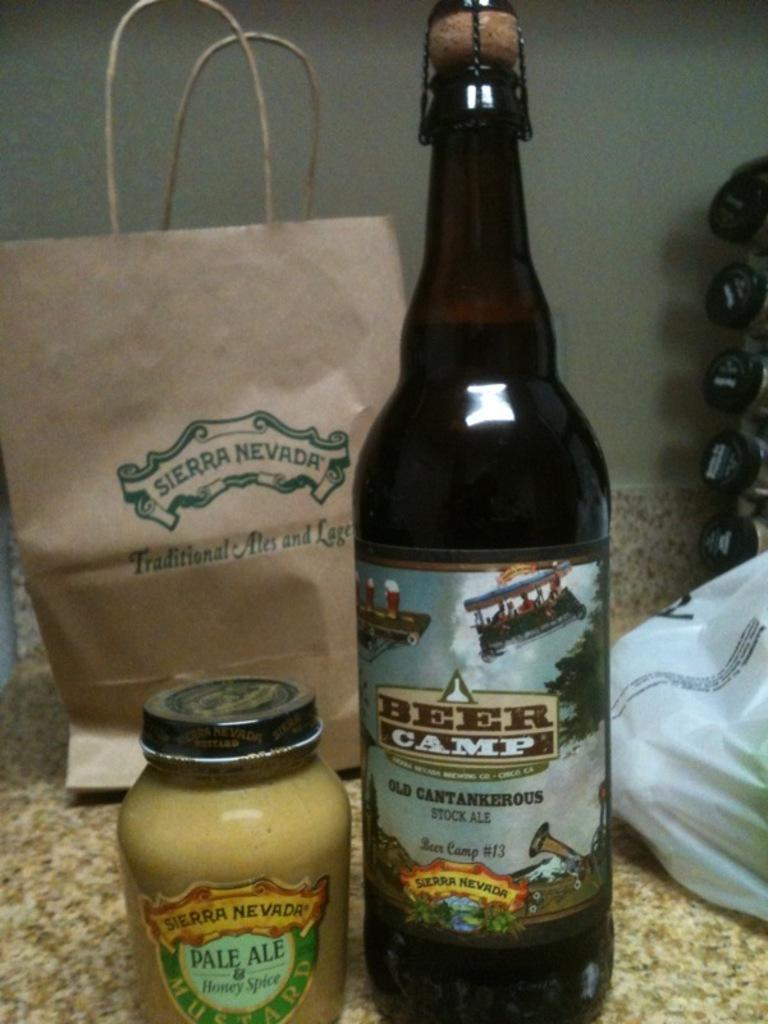Provide a one-sentence caption for the provided image. Among the items procured from Sierra Nevada: Pale Ale honey spice and Beer Camp stock ale. 